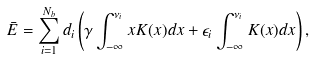Convert formula to latex. <formula><loc_0><loc_0><loc_500><loc_500>\bar { E } = \sum _ { i = 1 } ^ { N _ { b } } d _ { i } \left ( \gamma \int _ { - \infty } ^ { \nu _ { i } } x K ( x ) d x + \epsilon _ { i } \int _ { - \infty } ^ { \nu _ { i } } K ( x ) d x \right ) ,</formula> 